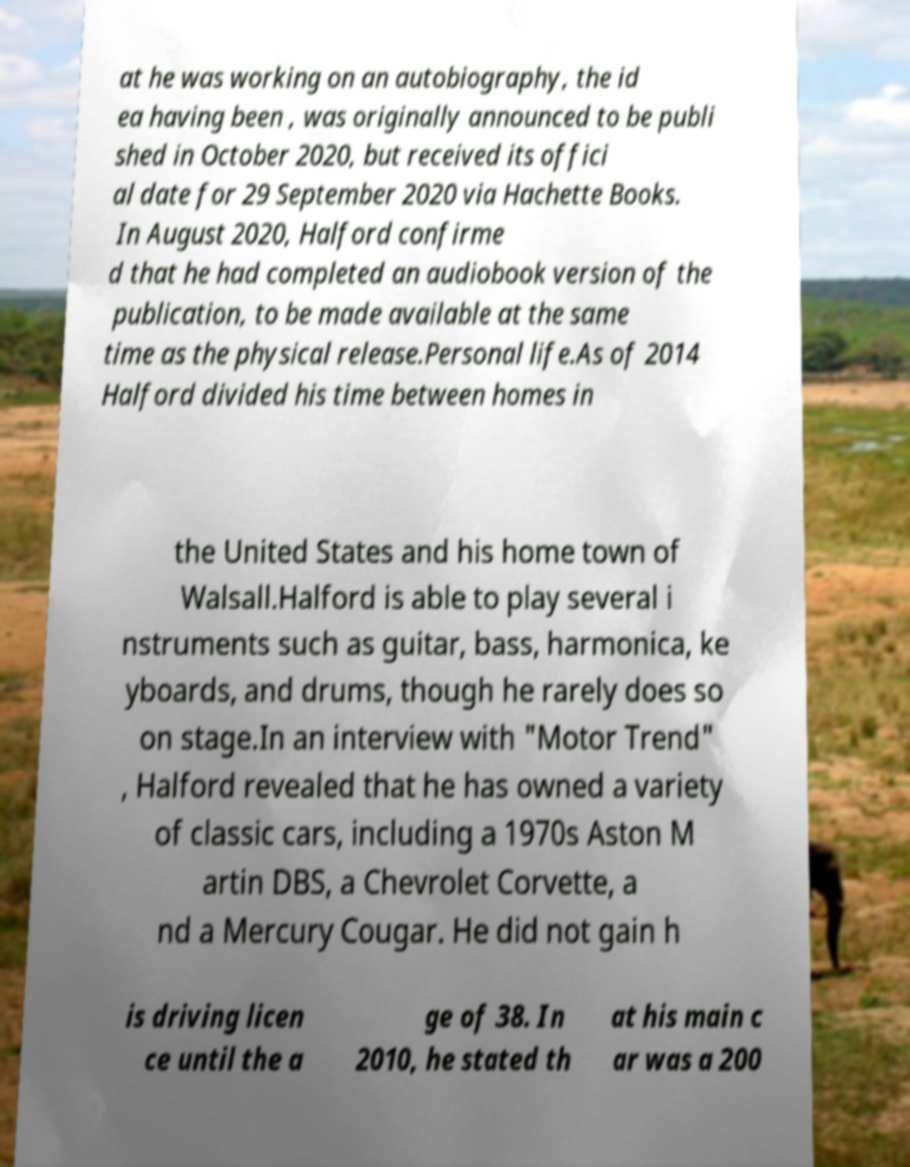I need the written content from this picture converted into text. Can you do that? at he was working on an autobiography, the id ea having been , was originally announced to be publi shed in October 2020, but received its offici al date for 29 September 2020 via Hachette Books. In August 2020, Halford confirme d that he had completed an audiobook version of the publication, to be made available at the same time as the physical release.Personal life.As of 2014 Halford divided his time between homes in the United States and his home town of Walsall.Halford is able to play several i nstruments such as guitar, bass, harmonica, ke yboards, and drums, though he rarely does so on stage.In an interview with "Motor Trend" , Halford revealed that he has owned a variety of classic cars, including a 1970s Aston M artin DBS, a Chevrolet Corvette, a nd a Mercury Cougar. He did not gain h is driving licen ce until the a ge of 38. In 2010, he stated th at his main c ar was a 200 